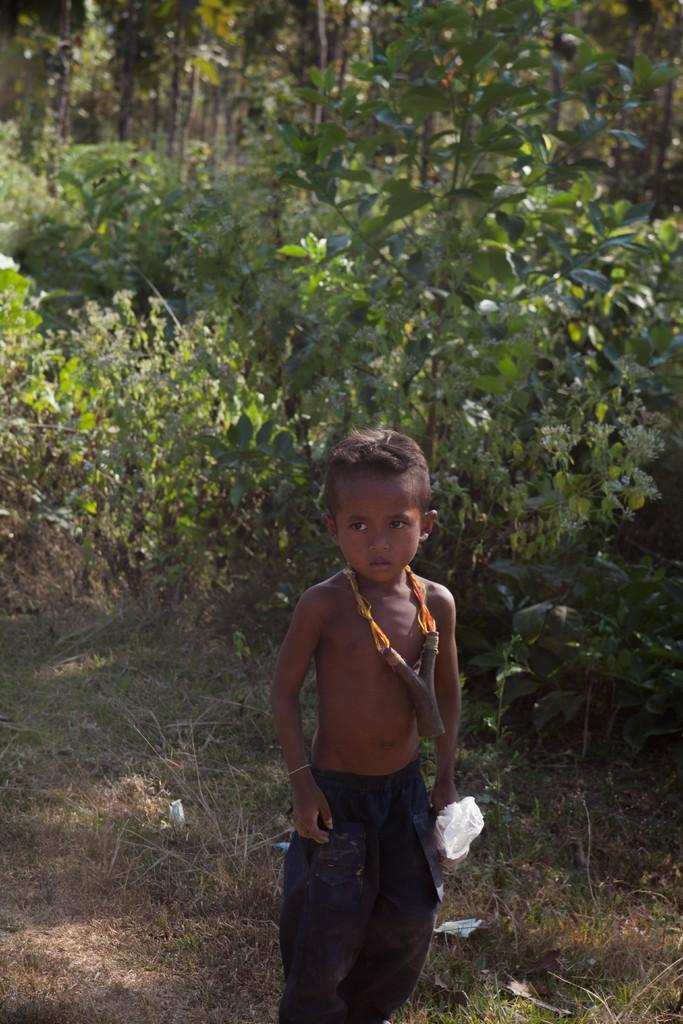Please provide a concise description of this image. This picture shows a boy and we see trees on the back and he is holding a carry bag in his hand and we see grass on the ground. 